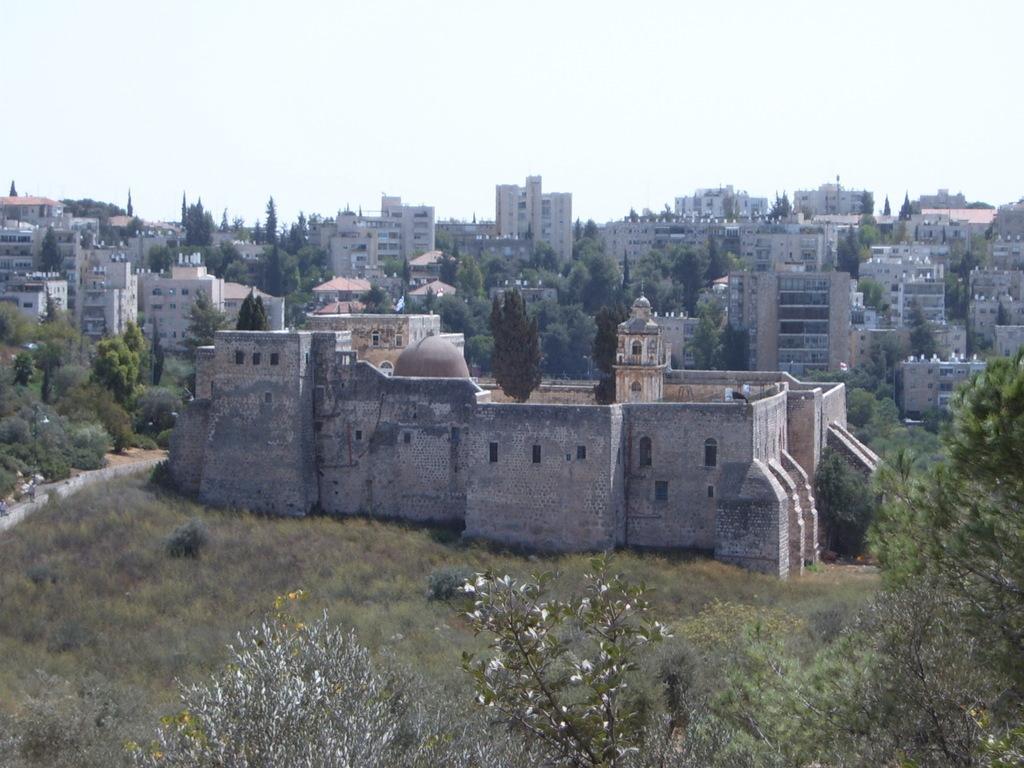Could you give a brief overview of what you see in this image? In the center of the image we can see the sky, buildings, windows, trees and a few other objects. 